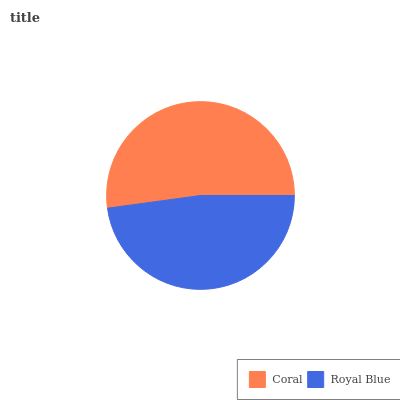Is Royal Blue the minimum?
Answer yes or no. Yes. Is Coral the maximum?
Answer yes or no. Yes. Is Royal Blue the maximum?
Answer yes or no. No. Is Coral greater than Royal Blue?
Answer yes or no. Yes. Is Royal Blue less than Coral?
Answer yes or no. Yes. Is Royal Blue greater than Coral?
Answer yes or no. No. Is Coral less than Royal Blue?
Answer yes or no. No. Is Coral the high median?
Answer yes or no. Yes. Is Royal Blue the low median?
Answer yes or no. Yes. Is Royal Blue the high median?
Answer yes or no. No. Is Coral the low median?
Answer yes or no. No. 